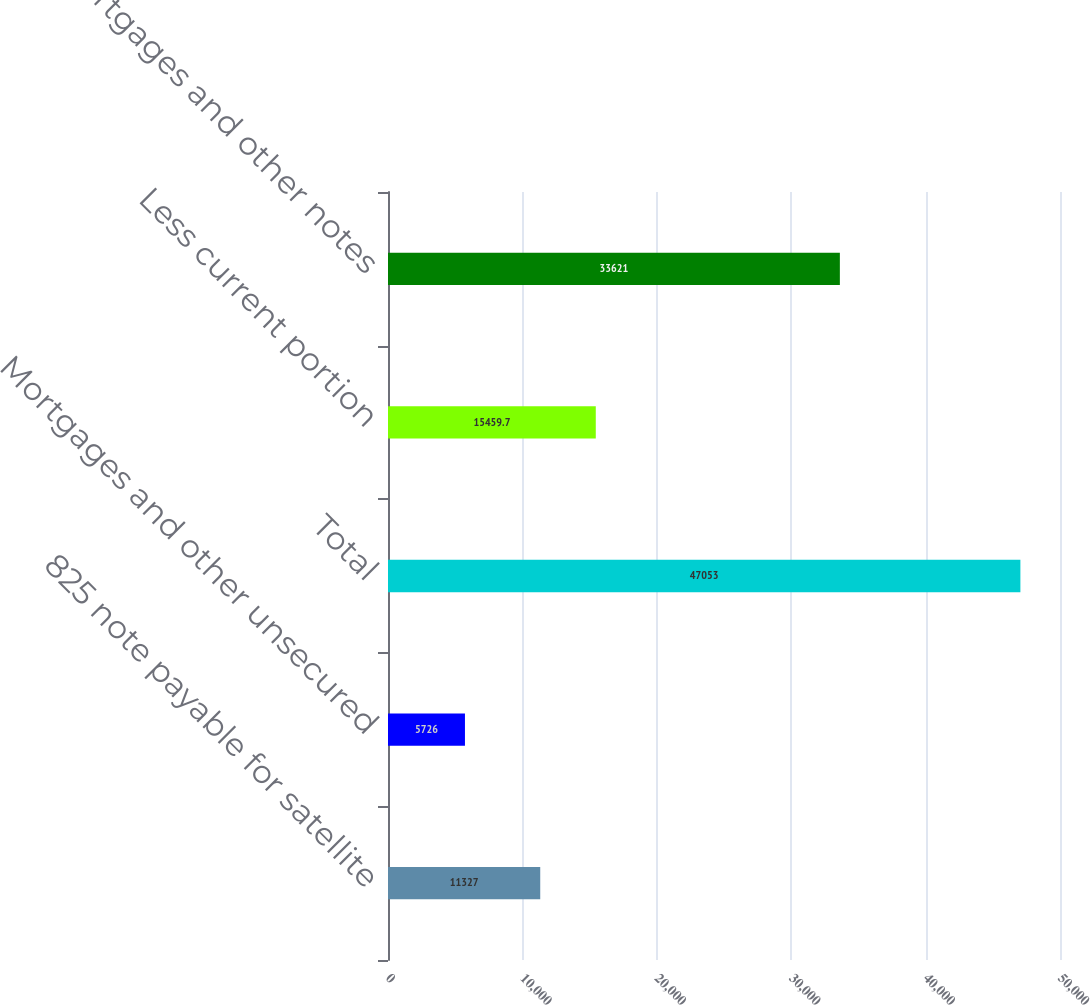Convert chart to OTSL. <chart><loc_0><loc_0><loc_500><loc_500><bar_chart><fcel>825 note payable for satellite<fcel>Mortgages and other unsecured<fcel>Total<fcel>Less current portion<fcel>Mortgages and other notes<nl><fcel>11327<fcel>5726<fcel>47053<fcel>15459.7<fcel>33621<nl></chart> 